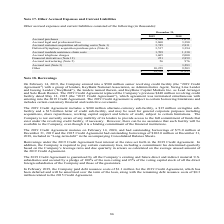According to Sykes Enterprises Incorporated's financial document, What was the amount of Accrued purchases in 2019? According to the financial document, $4,328 (in thousands). The relevant text states: "Accrued purchases $ 4,328 $ 1,679..." Also, What was the amount of Accrued legal and professional fees  in 2018? According to the financial document, 3,380 (in thousands). The relevant text states: "Accrued legal and professional fees 3,860 3,380..." Also, In which years were the Other accrued expenses and current liabilities calculated? The document shows two values: 2019 and 2018. From the document: "2019 2018 2019 2018..." Additionally, In which year were Accrued roadside assistance claim costs larger? According to the financial document, 2019. The relevant text states: "2019 2018..." Also, can you calculate: What was the change in Accrued roadside assistance claim costs in 2019 from 2018? Based on the calculation: 1,709-1,330, the result is 379 (in thousands). This is based on the information: "Accrued roadside assistance claim costs 1,709 1,330 Accrued roadside assistance claim costs 1,709 1,330..." The key data points involved are: 1,330, 1,709. Also, can you calculate: What was the percentage change in Accrued roadside assistance claim costs in 2019 from 2018? To answer this question, I need to perform calculations using the financial data. The calculation is: (1,709-1,330)/1,330, which equals 28.5 (percentage). This is based on the information: "Accrued roadside assistance claim costs 1,709 1,330 Accrued roadside assistance claim costs 1,709 1,330..." The key data points involved are: 1,330, 1,709. 